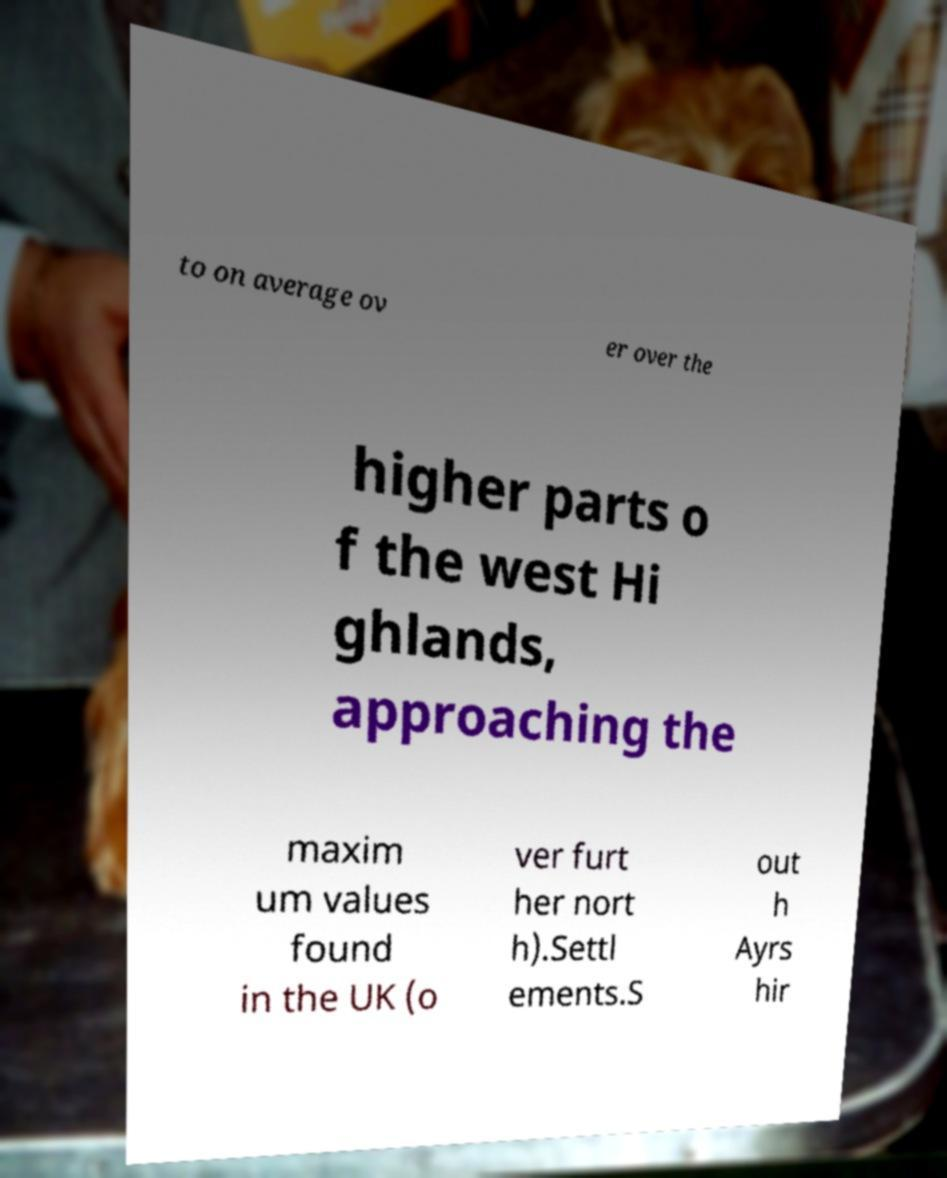I need the written content from this picture converted into text. Can you do that? to on average ov er over the higher parts o f the west Hi ghlands, approaching the maxim um values found in the UK (o ver furt her nort h).Settl ements.S out h Ayrs hir 